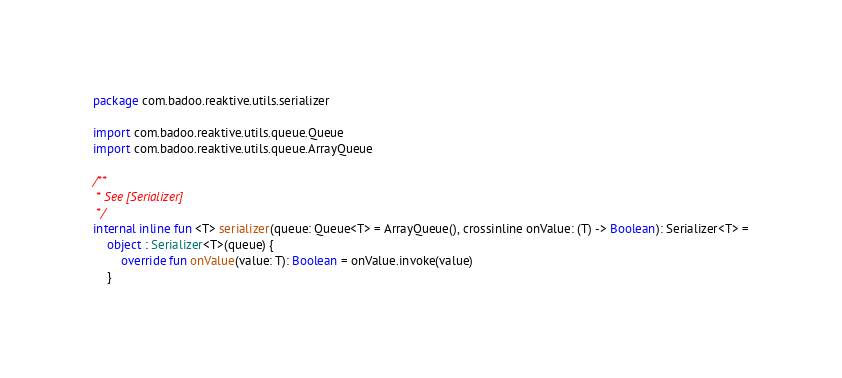<code> <loc_0><loc_0><loc_500><loc_500><_Kotlin_>package com.badoo.reaktive.utils.serializer

import com.badoo.reaktive.utils.queue.Queue
import com.badoo.reaktive.utils.queue.ArrayQueue

/**
 * See [Serializer]
 */
internal inline fun <T> serializer(queue: Queue<T> = ArrayQueue(), crossinline onValue: (T) -> Boolean): Serializer<T> =
    object : Serializer<T>(queue) {
        override fun onValue(value: T): Boolean = onValue.invoke(value)
    }</code> 